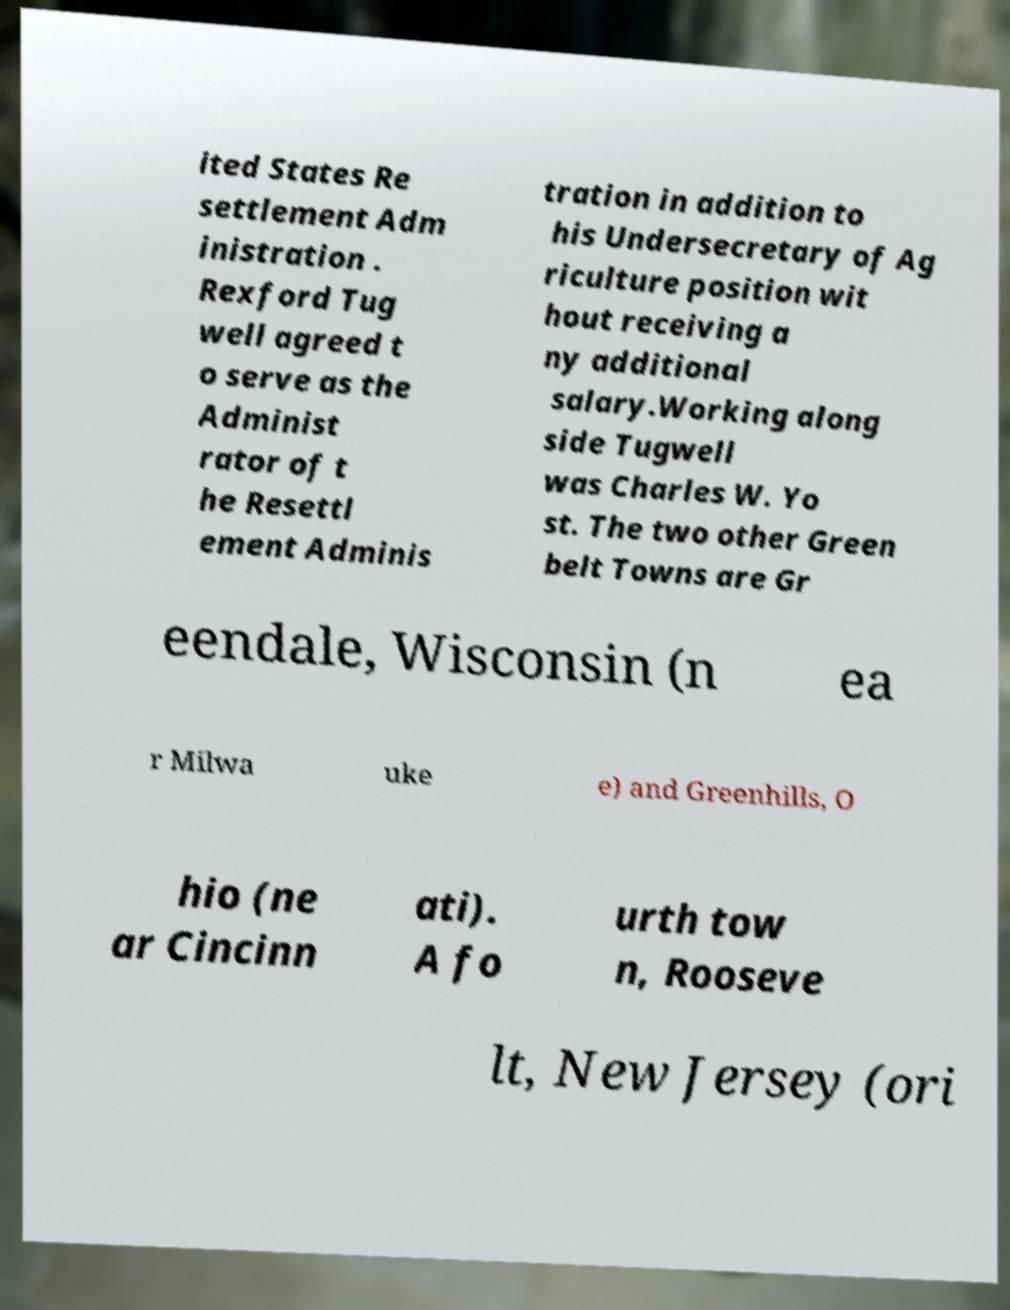Could you assist in decoding the text presented in this image and type it out clearly? ited States Re settlement Adm inistration . Rexford Tug well agreed t o serve as the Administ rator of t he Resettl ement Adminis tration in addition to his Undersecretary of Ag riculture position wit hout receiving a ny additional salary.Working along side Tugwell was Charles W. Yo st. The two other Green belt Towns are Gr eendale, Wisconsin (n ea r Milwa uke e) and Greenhills, O hio (ne ar Cincinn ati). A fo urth tow n, Rooseve lt, New Jersey (ori 